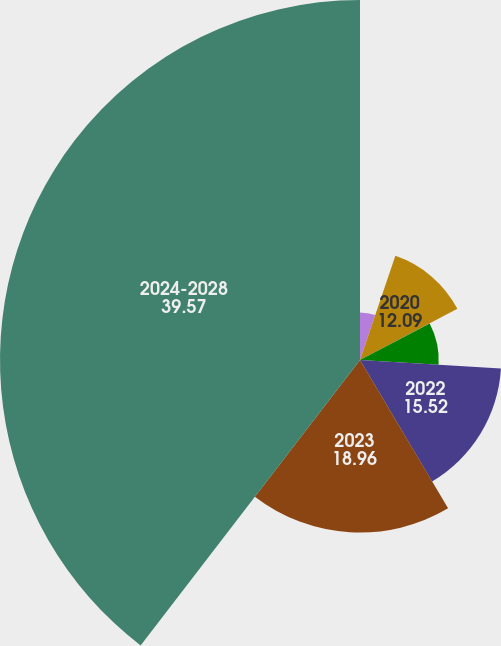Convert chart. <chart><loc_0><loc_0><loc_500><loc_500><pie_chart><fcel>2019<fcel>2020<fcel>2021<fcel>2022<fcel>2023<fcel>2024-2028<nl><fcel>5.21%<fcel>12.09%<fcel>8.65%<fcel>15.52%<fcel>18.96%<fcel>39.57%<nl></chart> 